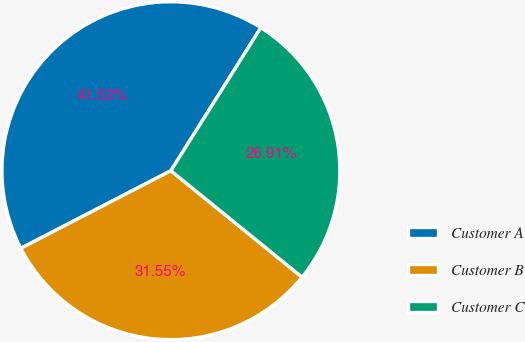<chart> <loc_0><loc_0><loc_500><loc_500><pie_chart><fcel>Customer A<fcel>Customer B<fcel>Customer C<nl><fcel>41.53%<fcel>31.55%<fcel>26.91%<nl></chart> 